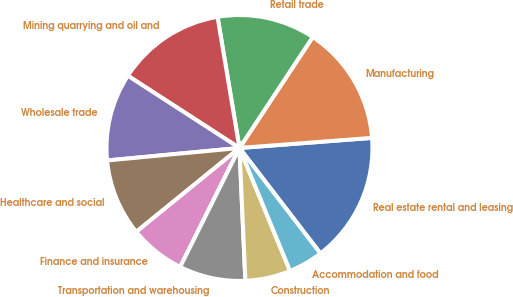Convert chart to OTSL. <chart><loc_0><loc_0><loc_500><loc_500><pie_chart><fcel>Real estate rental and leasing<fcel>Manufacturing<fcel>Retail trade<fcel>Mining quarrying and oil and<fcel>Wholesale trade<fcel>Healthcare and social<fcel>Finance and insurance<fcel>Transportation and warehousing<fcel>Construction<fcel>Accommodation and food<nl><fcel>15.79%<fcel>14.5%<fcel>11.93%<fcel>13.22%<fcel>10.64%<fcel>9.36%<fcel>6.78%<fcel>8.07%<fcel>5.5%<fcel>4.21%<nl></chart> 